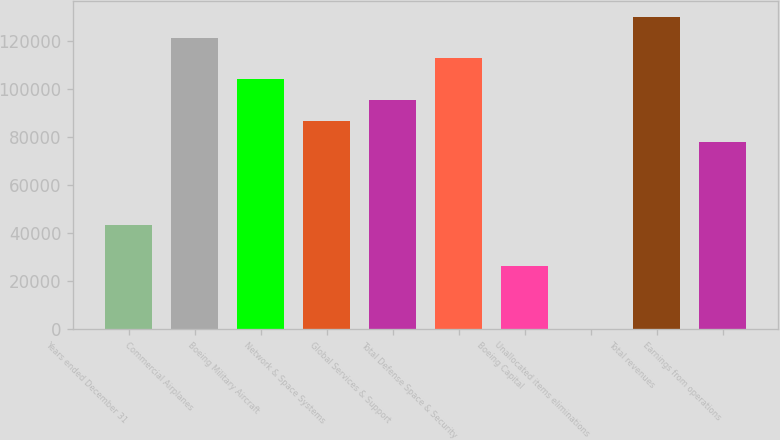Convert chart to OTSL. <chart><loc_0><loc_0><loc_500><loc_500><bar_chart><fcel>Years ended December 31<fcel>Commercial Airplanes<fcel>Boeing Military Aircraft<fcel>Network & Space Systems<fcel>Global Services & Support<fcel>Total Defense Space & Security<fcel>Boeing Capital<fcel>Unallocated items eliminations<fcel>Total revenues<fcel>Earnings from operations<nl><fcel>43330<fcel>121257<fcel>103940<fcel>86623<fcel>95281.6<fcel>112599<fcel>26012.8<fcel>37<fcel>129916<fcel>77964.4<nl></chart> 